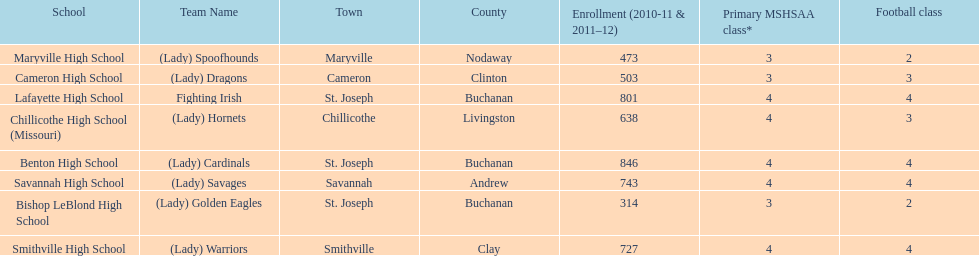Which schools are in the same town as bishop leblond? Benton High School, Lafayette High School. 